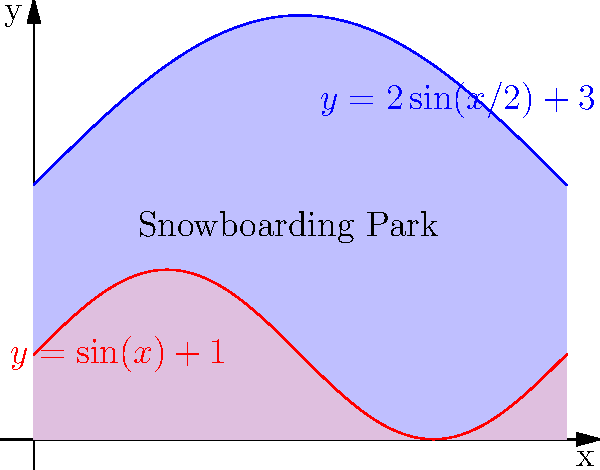A new snowboarding park in the Australian Alps has an irregular shape. The upper boundary of the park is defined by the function $y = 2\sin(x/2) + 3$, and the lower boundary is defined by $y = \sin(x) + 1$, where $x$ and $y$ are measured in kilometers. If the park extends from $x = 0$ to $x = 2\pi$ km, what is the total area of the snowboarding park in square kilometers? To find the area of the irregularly shaped snowboarding park, we need to use integration to calculate the area between the two curves. Here's how we can do it step-by-step:

1) The area between two curves is given by the formula:

   $$A = \int_{a}^{b} [f(x) - g(x)] dx$$

   where $f(x)$ is the upper function and $g(x)$ is the lower function.

2) In this case:
   $f(x) = 2\sin(x/2) + 3$
   $g(x) = \sin(x) + 1$
   $a = 0$ and $b = 2\pi$

3) Substituting these into our formula:

   $$A = \int_{0}^{2\pi} [(2\sin(x/2) + 3) - (\sin(x) + 1)] dx$$

4) Simplify the integrand:

   $$A = \int_{0}^{2\pi} [2\sin(x/2) - \sin(x) + 2] dx$$

5) Now we integrate each term:

   $$A = [-4\cos(x/2) + \cos(x) + 2x]_{0}^{2\pi}$$

6) Evaluate the integral at the limits:

   $$A = [-4\cos(\pi) + \cos(2\pi) + 4\pi] - [-4\cos(0) + \cos(0) + 0]$$

7) Simplify:

   $$A = [4 + 1 + 4\pi] - [-4 + 1 + 0] = 5 + 4\pi - (-3) = 4\pi + 8$$

Therefore, the area of the snowboarding park is $4\pi + 8$ square kilometers.
Answer: $4\pi + 8$ sq km 